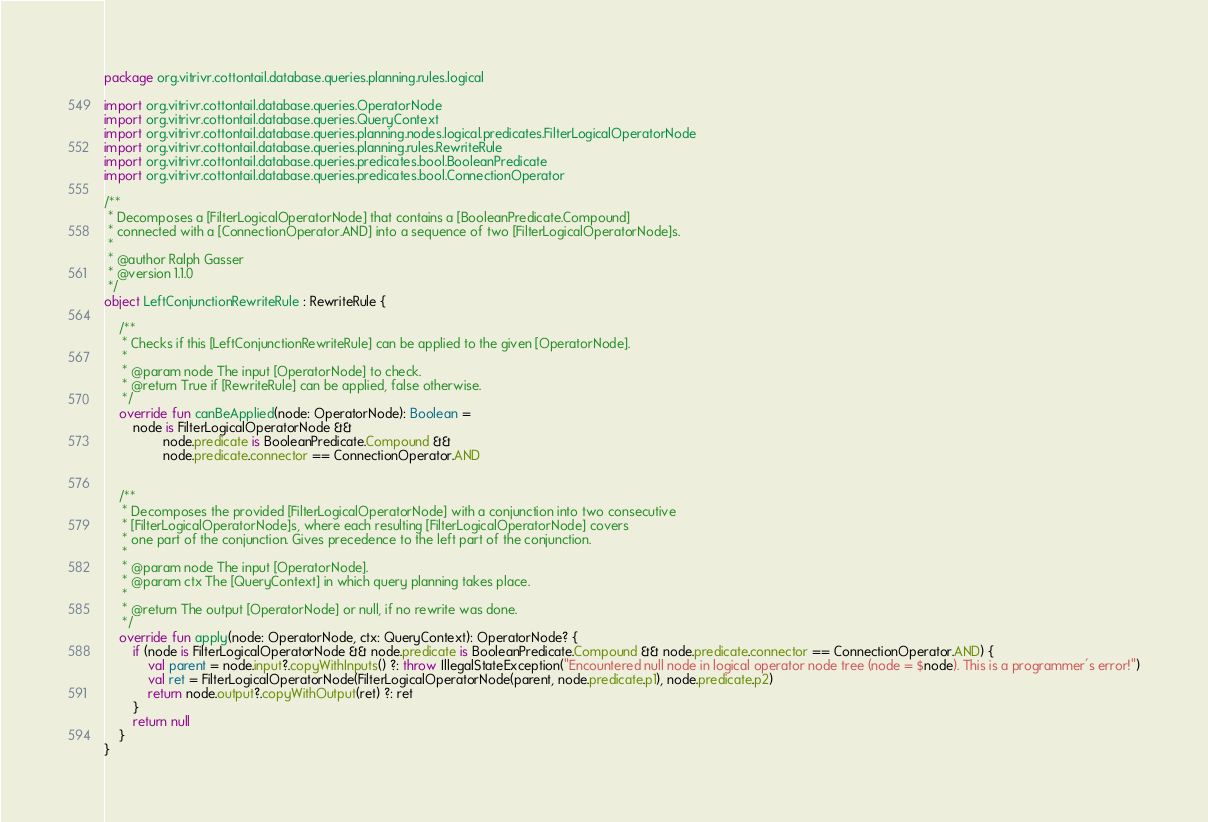<code> <loc_0><loc_0><loc_500><loc_500><_Kotlin_>package org.vitrivr.cottontail.database.queries.planning.rules.logical

import org.vitrivr.cottontail.database.queries.OperatorNode
import org.vitrivr.cottontail.database.queries.QueryContext
import org.vitrivr.cottontail.database.queries.planning.nodes.logical.predicates.FilterLogicalOperatorNode
import org.vitrivr.cottontail.database.queries.planning.rules.RewriteRule
import org.vitrivr.cottontail.database.queries.predicates.bool.BooleanPredicate
import org.vitrivr.cottontail.database.queries.predicates.bool.ConnectionOperator

/**
 * Decomposes a [FilterLogicalOperatorNode] that contains a [BooleanPredicate.Compound]
 * connected with a [ConnectionOperator.AND] into a sequence of two [FilterLogicalOperatorNode]s.
 *
 * @author Ralph Gasser
 * @version 1.1.0
 */
object LeftConjunctionRewriteRule : RewriteRule {

    /**
     * Checks if this [LeftConjunctionRewriteRule] can be applied to the given [OperatorNode].
     *
     * @param node The input [OperatorNode] to check.
     * @return True if [RewriteRule] can be applied, false otherwise.
     */
    override fun canBeApplied(node: OperatorNode): Boolean =
        node is FilterLogicalOperatorNode &&
                node.predicate is BooleanPredicate.Compound &&
                node.predicate.connector == ConnectionOperator.AND


    /**
     * Decomposes the provided [FilterLogicalOperatorNode] with a conjunction into two consecutive
     * [FilterLogicalOperatorNode]s, where each resulting [FilterLogicalOperatorNode] covers
     * one part of the conjunction. Gives precedence to the left part of the conjunction.
     *
     * @param node The input [OperatorNode].
     * @param ctx The [QueryContext] in which query planning takes place.
     *
     * @return The output [OperatorNode] or null, if no rewrite was done.
     */
    override fun apply(node: OperatorNode, ctx: QueryContext): OperatorNode? {
        if (node is FilterLogicalOperatorNode && node.predicate is BooleanPredicate.Compound && node.predicate.connector == ConnectionOperator.AND) {
            val parent = node.input?.copyWithInputs() ?: throw IllegalStateException("Encountered null node in logical operator node tree (node = $node). This is a programmer's error!")
            val ret = FilterLogicalOperatorNode(FilterLogicalOperatorNode(parent, node.predicate.p1), node.predicate.p2)
            return node.output?.copyWithOutput(ret) ?: ret
        }
        return null
    }
}</code> 